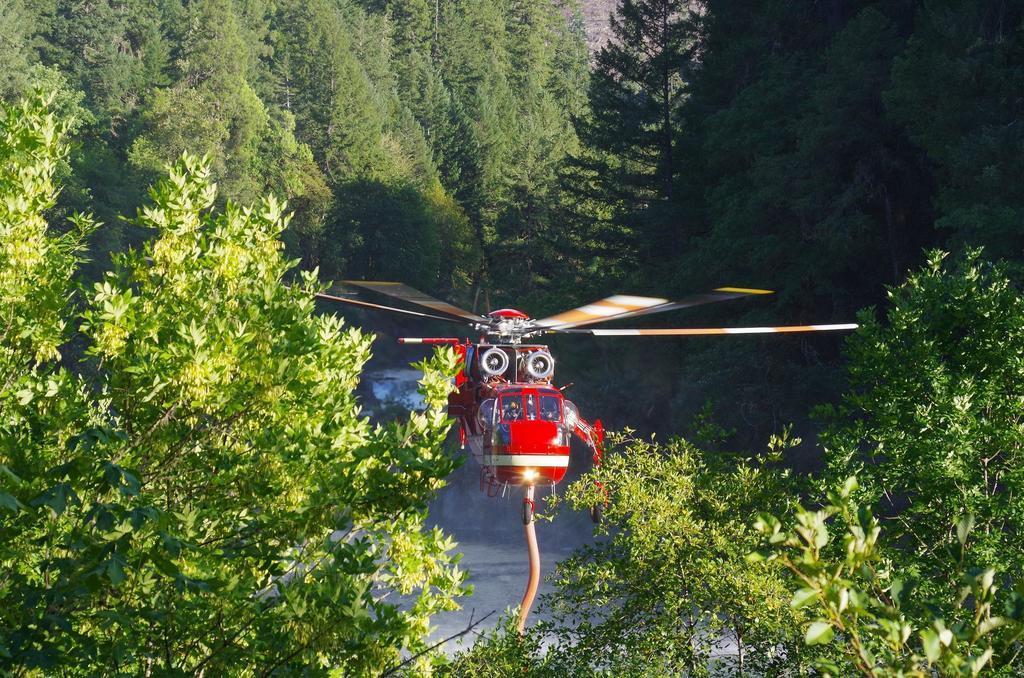Could you give a brief overview of what you see in this image? In this image we can see a red color helicopter in the air, around it trees are present. In the middle of the tree water is there. 